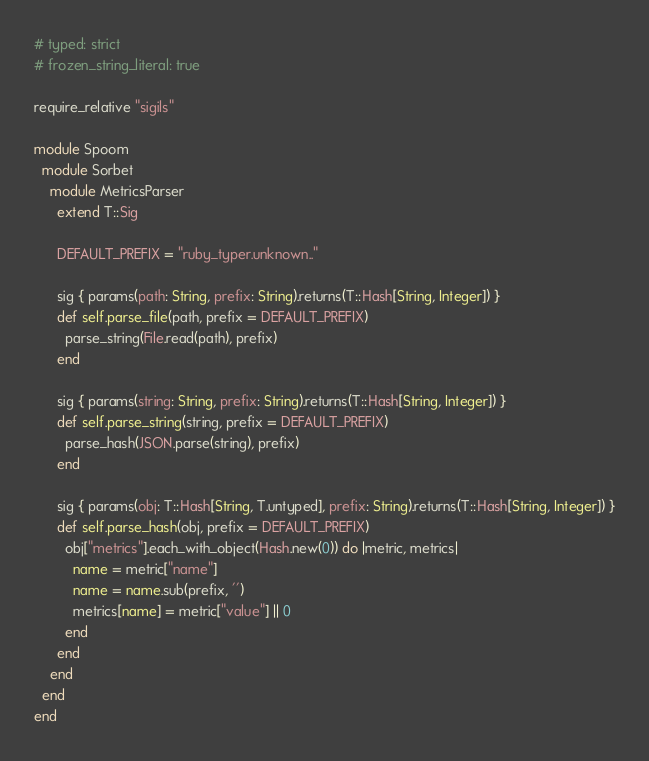<code> <loc_0><loc_0><loc_500><loc_500><_Ruby_># typed: strict
# frozen_string_literal: true

require_relative "sigils"

module Spoom
  module Sorbet
    module MetricsParser
      extend T::Sig

      DEFAULT_PREFIX = "ruby_typer.unknown.."

      sig { params(path: String, prefix: String).returns(T::Hash[String, Integer]) }
      def self.parse_file(path, prefix = DEFAULT_PREFIX)
        parse_string(File.read(path), prefix)
      end

      sig { params(string: String, prefix: String).returns(T::Hash[String, Integer]) }
      def self.parse_string(string, prefix = DEFAULT_PREFIX)
        parse_hash(JSON.parse(string), prefix)
      end

      sig { params(obj: T::Hash[String, T.untyped], prefix: String).returns(T::Hash[String, Integer]) }
      def self.parse_hash(obj, prefix = DEFAULT_PREFIX)
        obj["metrics"].each_with_object(Hash.new(0)) do |metric, metrics|
          name = metric["name"]
          name = name.sub(prefix, '')
          metrics[name] = metric["value"] || 0
        end
      end
    end
  end
end
</code> 